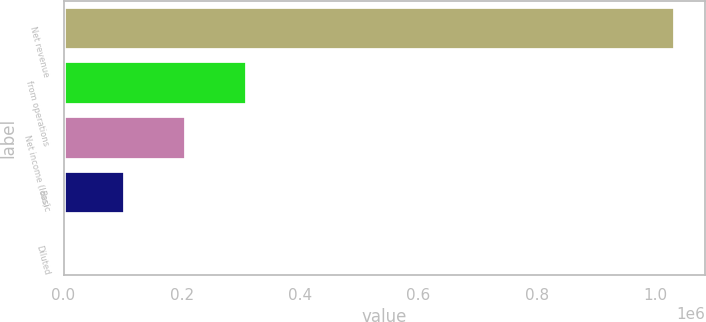Convert chart to OTSL. <chart><loc_0><loc_0><loc_500><loc_500><bar_chart><fcel>Net revenue<fcel>from operations<fcel>Net income (loss)<fcel>Basic<fcel>Diluted<nl><fcel>1.03369e+06<fcel>310109<fcel>206740<fcel>103371<fcel>1.37<nl></chart> 